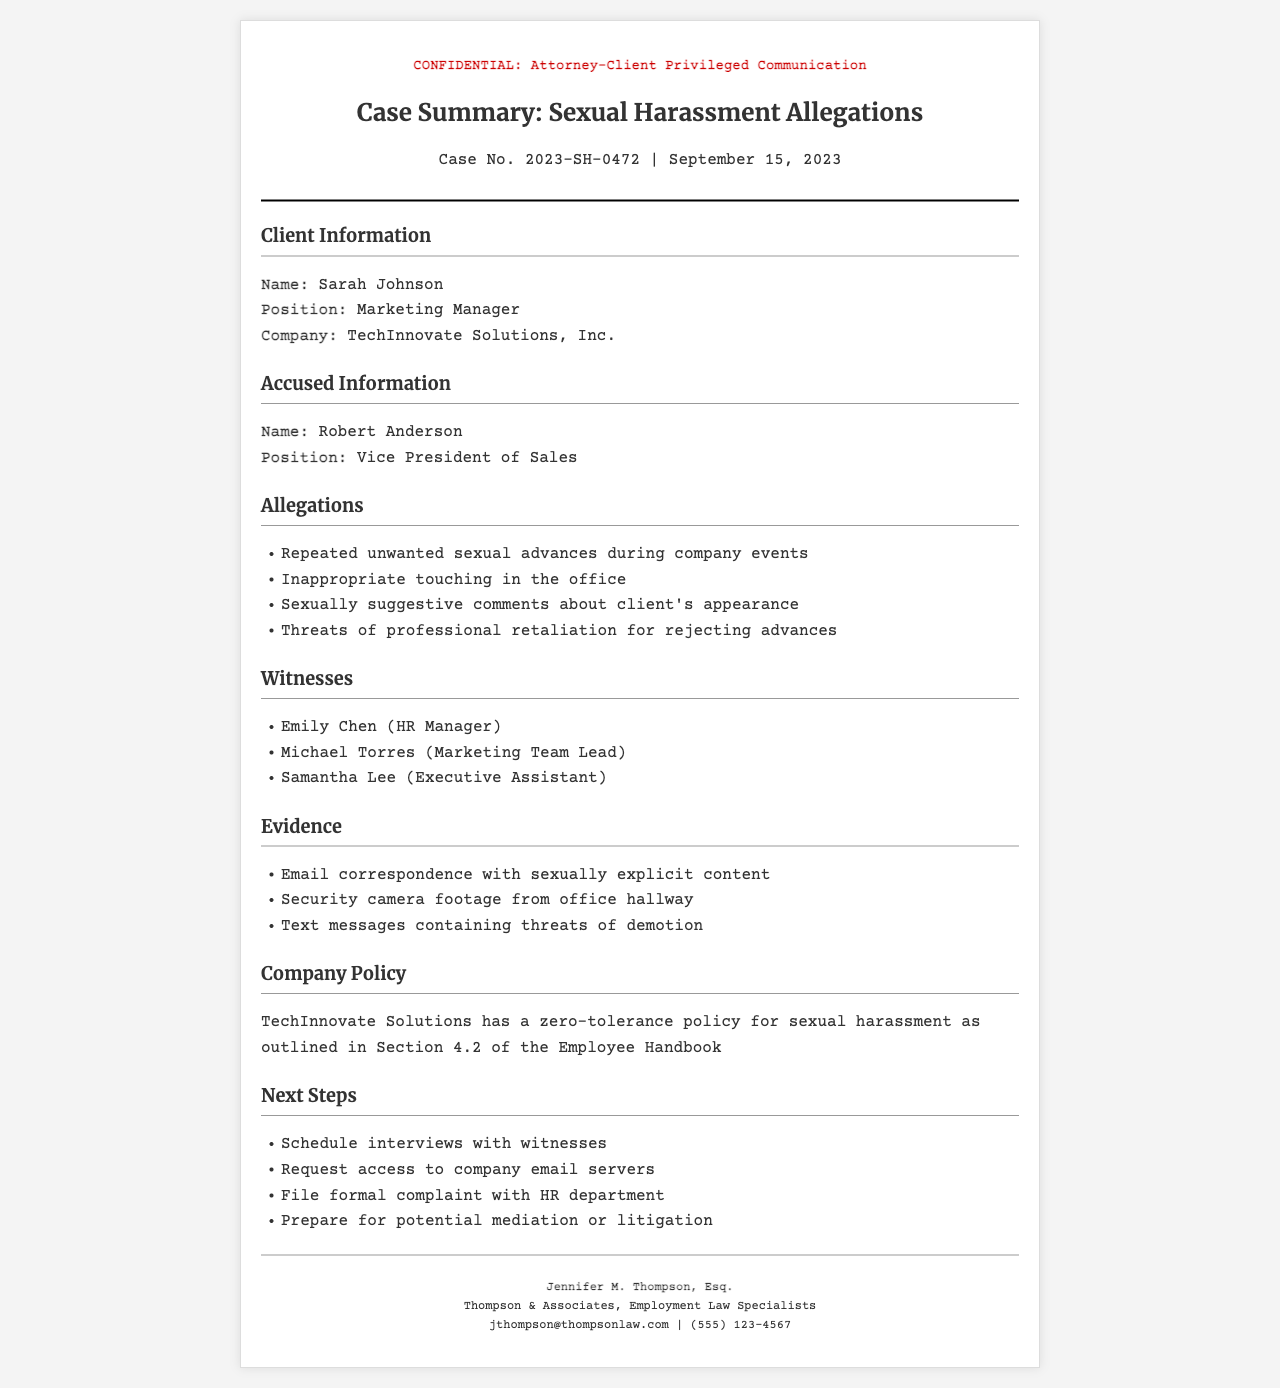What is the client's name? The client's name is mentioned in the Client Information section of the document.
Answer: Sarah Johnson Who is the accused? The accused person's name is specified under the Accused Information section of the document.
Answer: Robert Anderson What is the case number? The case number is listed in the header of the document.
Answer: 2023-SH-0472 Which company does the client work for? The company name is mentioned in the Client Information section.
Answer: TechInnovate Solutions, Inc What is one of the allegations against the accused? The allegations are listed in the Allegations section, and I can refer to the first item.
Answer: Repeated unwanted sexual advances during company events Who is the HR Manager listed as a witness? The witness names are provided in the Witnesses section with roles.
Answer: Emily Chen What type of company policy is mentioned? The document details the company's stance on workplace misconduct, found in the Company Policy section.
Answer: Zero-tolerance policy for sexual harassment What is one piece of evidence listed? Evidence items are detailed in the Evidence section, and I can refer to the first item.
Answer: Email correspondence with sexually explicit content What is one next step listed for the case? The next steps are outlined in the Next Steps section, I can mention the first item.
Answer: Schedule interviews with witnesses 